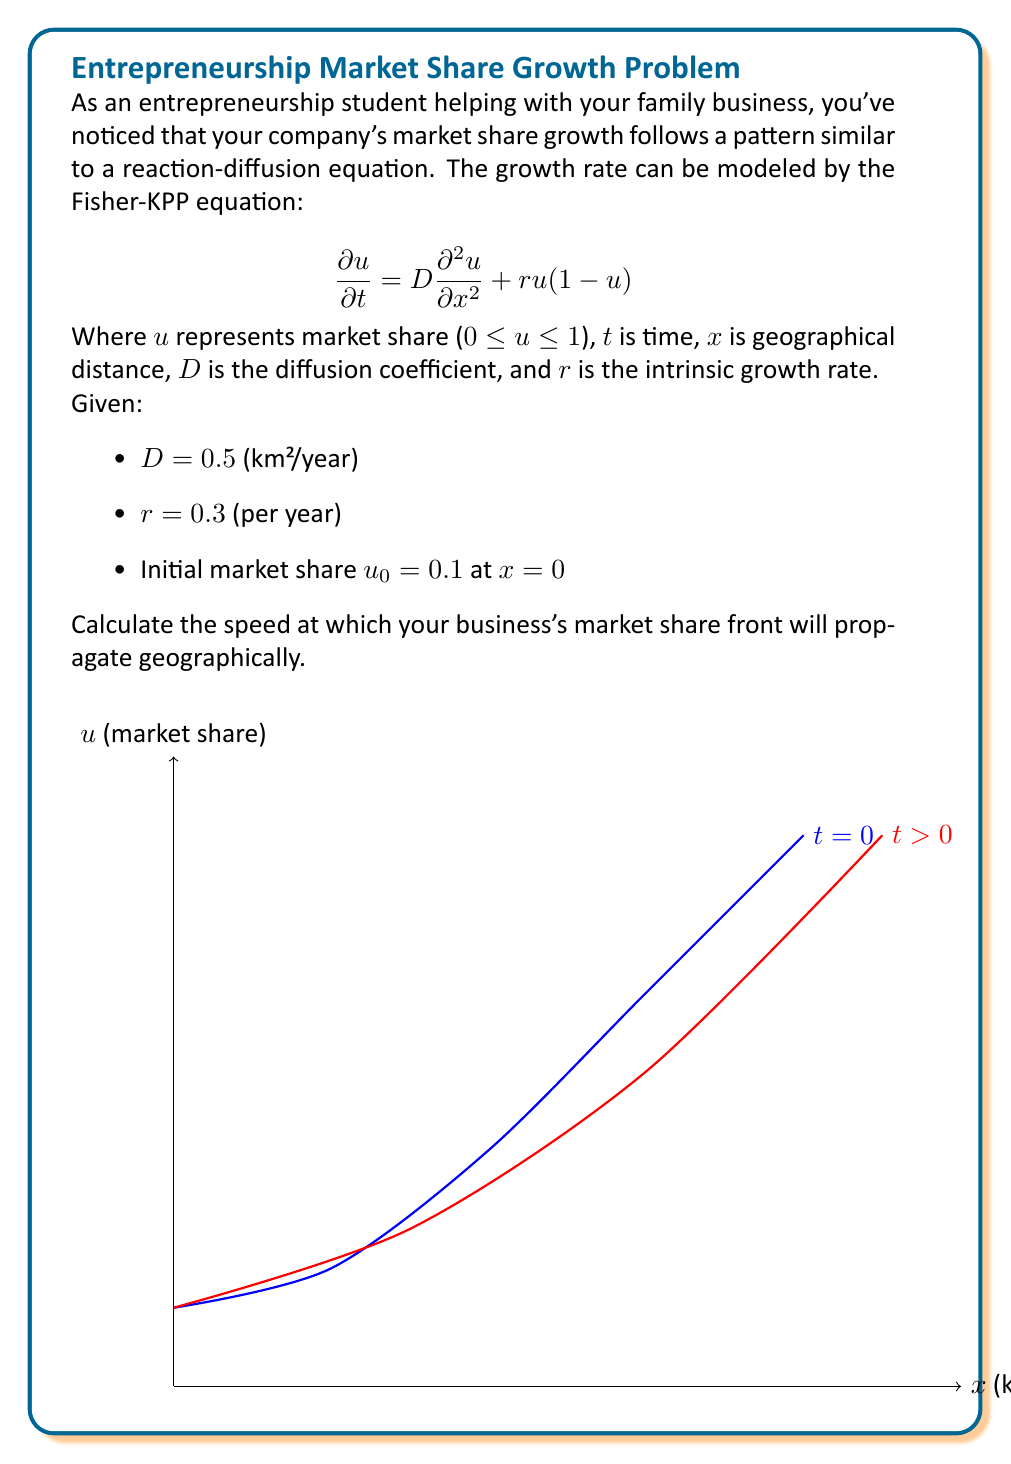Solve this math problem. To solve this problem, we'll use the formula for the asymptotic speed of propagation for the Fisher-KPP equation:

1) The formula for the speed of propagation is:

   $$c = 2\sqrt{Dr}$$

2) We're given:
   - $D = 0.5$ km²/year (diffusion coefficient)
   - $r = 0.3$ per year (intrinsic growth rate)

3) Let's substitute these values into the formula:

   $$c = 2\sqrt{(0.5)(0.3)}$$

4) Simplify under the square root:

   $$c = 2\sqrt{0.15}$$

5) Calculate the square root:

   $$c = 2(0.3873)$$

6) Multiply:

   $$c = 0.7746$$ km/year

Therefore, the market share front will propagate at a speed of approximately 0.7746 km per year.

Note: The initial market share ($u_0$) and its location ($x = 0$) don't affect the asymptotic speed of propagation in this model.
Answer: 0.7746 km/year 